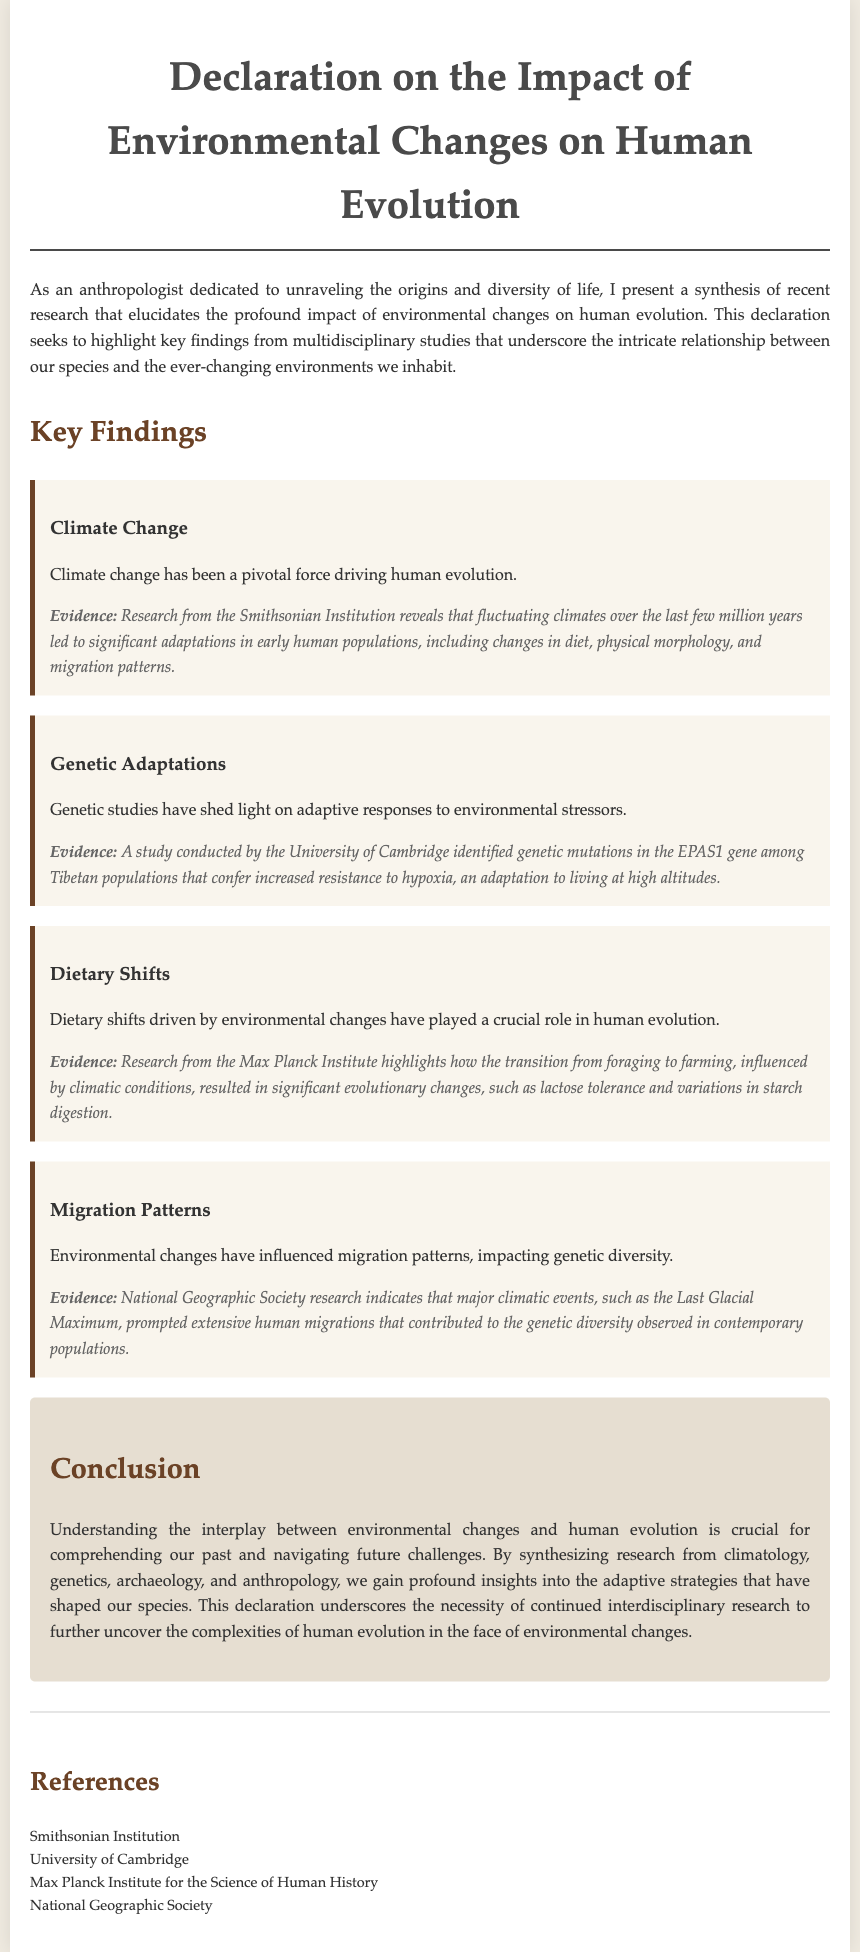What is the title of the document? The title of the document is stated prominently at the beginning, summarizing its central theme.
Answer: Declaration on the Impact of Environmental Changes on Human Evolution Who conducted research on adaptations in early human populations? The document references an institution that provides important research findings related to human evolution amid environmental changes.
Answer: Smithsonian Institution What genetic adaptation is discussed in relation to Tibetan populations? The document mentions a specific genetic mutation that aids survival under high altitude conditions, providing key insight into the adaptive responses of humans.
Answer: EPAS1 gene What crucial shift influenced significant evolutionary changes according to the document? The document highlights a specific transition in human behavior impacted by environmental factors, which had profound implications on evolution.
Answer: Foraging to farming Which climatic event prompted extensive human migrations? A historical climatic phase that significantly affected human distribution patterns is noted in the document as pivotal in shaping human genetic diversity.
Answer: Last Glacial Maximum What is emphasized as crucial for understanding human evolution? The conclusion summarizes the importance of a particular interdisciplinary approach to grasping the dynamics of human development influenced by environmental factors.
Answer: Interdisciplinary research 